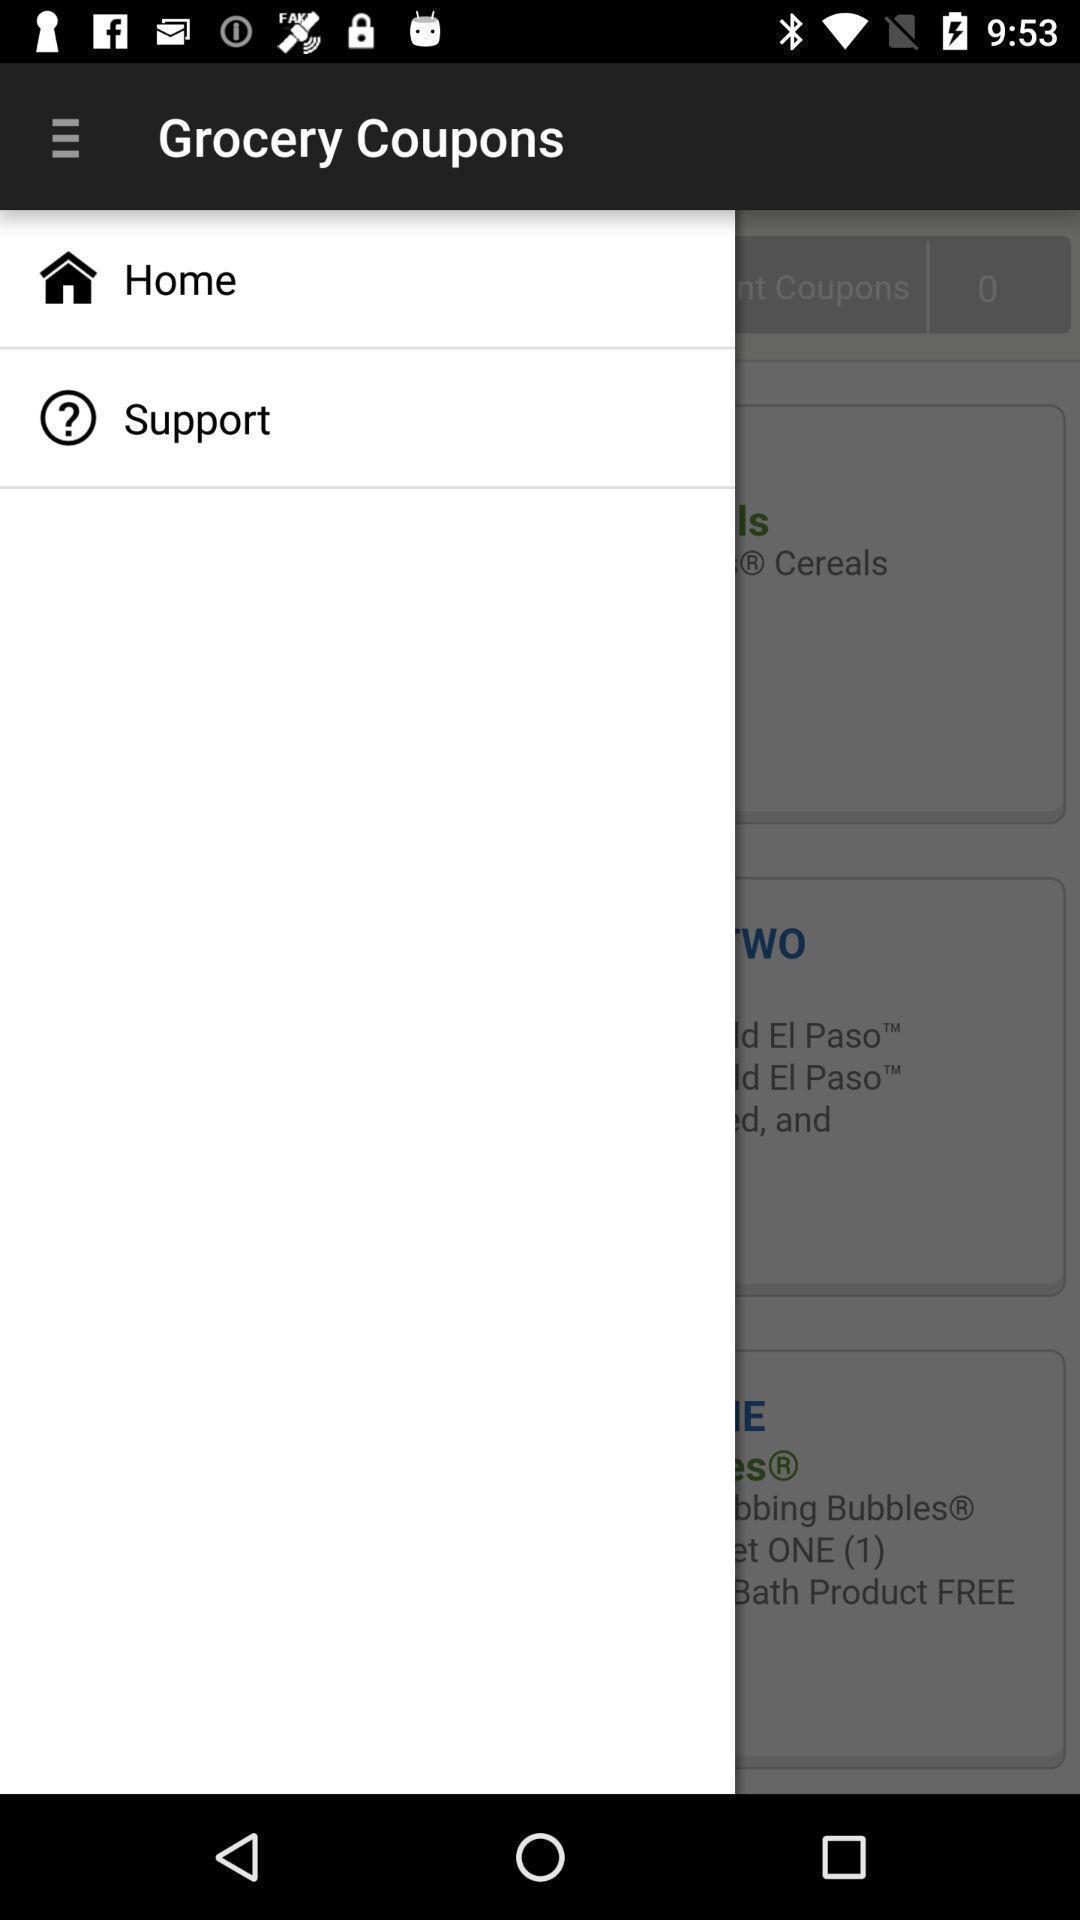Provide a description of this screenshot. Page displaying the coupons of the store. 